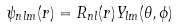Convert formula to latex. <formula><loc_0><loc_0><loc_500><loc_500>\psi _ { n l m } ( r ) = R _ { n l } ( r ) Y _ { l m } ( \theta , \phi )</formula> 